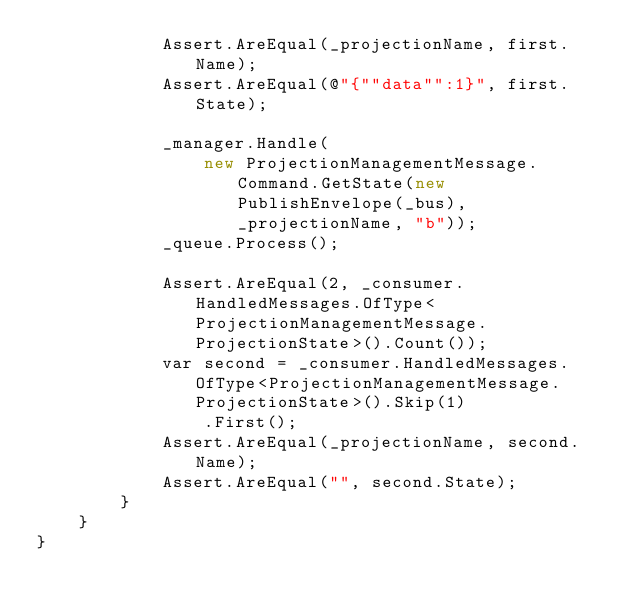Convert code to text. <code><loc_0><loc_0><loc_500><loc_500><_C#_>			Assert.AreEqual(_projectionName, first.Name);
			Assert.AreEqual(@"{""data"":1}", first.State);

			_manager.Handle(
				new ProjectionManagementMessage.Command.GetState(new PublishEnvelope(_bus), _projectionName, "b"));
			_queue.Process();

			Assert.AreEqual(2, _consumer.HandledMessages.OfType<ProjectionManagementMessage.ProjectionState>().Count());
			var second = _consumer.HandledMessages.OfType<ProjectionManagementMessage.ProjectionState>().Skip(1)
				.First();
			Assert.AreEqual(_projectionName, second.Name);
			Assert.AreEqual("", second.State);
		}
	}
}
</code> 